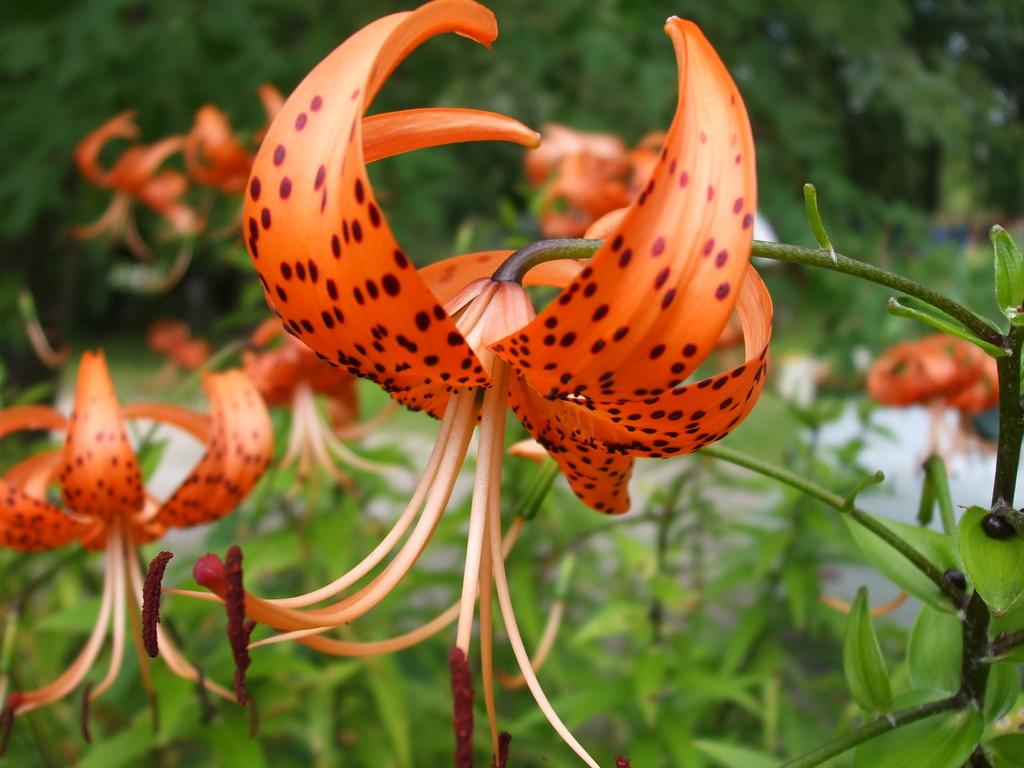What type of plants can be seen in the image? There are flowers in the image. What part of the flowers is visible in the image? There are leaves on the stems of the flowers. What can be seen in the background of the image? There are trees visible in the background of the image. How many feet are visible in the image? There are no feet present in the image; it features flowers and trees. What type of grip can be seen on the flowers in the image? There is no grip visible on the flowers in the image; they are simply depicted with leaves on their stems. 